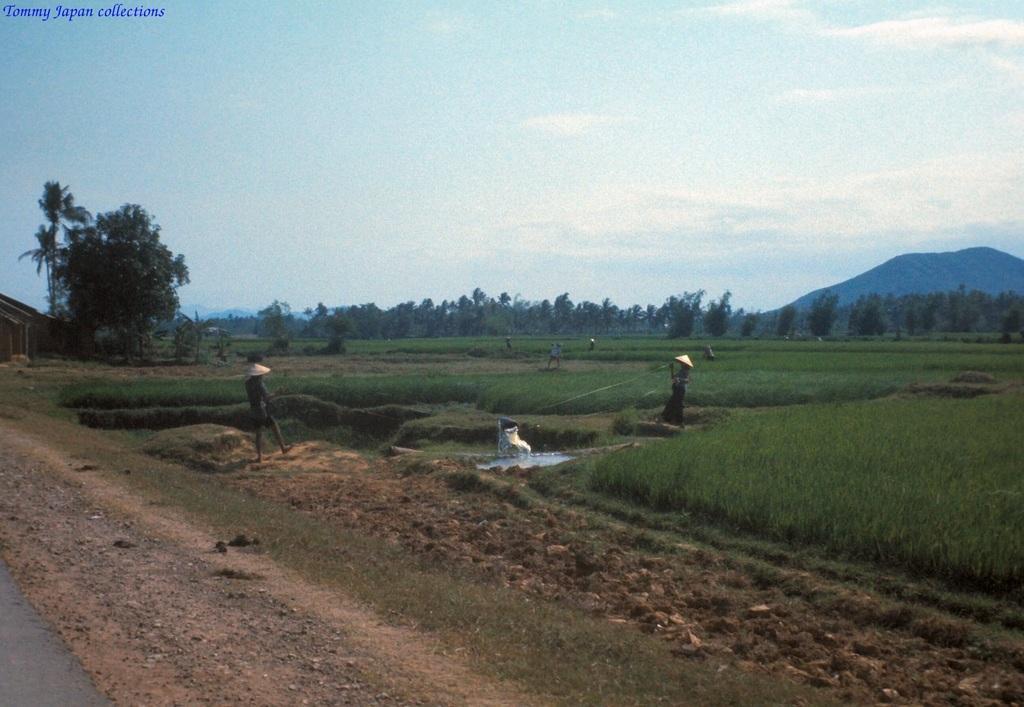How would you summarize this image in a sentence or two? In the center of the image we can see some plants and some persons, trees are there. At the top of the image clouds are present in the sky. On the right side of the image hills are there. On the left side of the image we can see a hut, road, ground are present. 